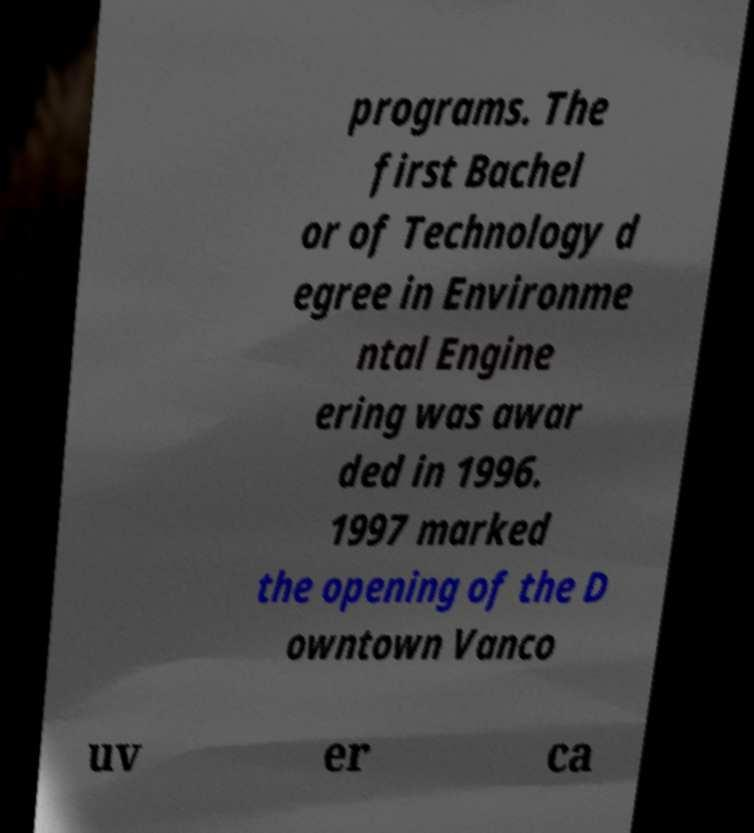Can you accurately transcribe the text from the provided image for me? programs. The first Bachel or of Technology d egree in Environme ntal Engine ering was awar ded in 1996. 1997 marked the opening of the D owntown Vanco uv er ca 